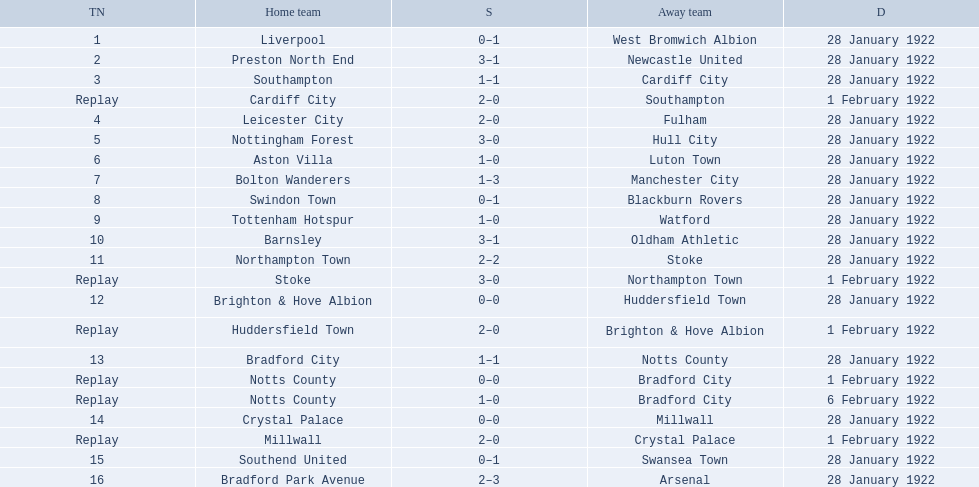Which team had a score of 0-1? Liverpool. Which team had a replay? Cardiff City. Which team had the same score as aston villa? Tottenham Hotspur. 